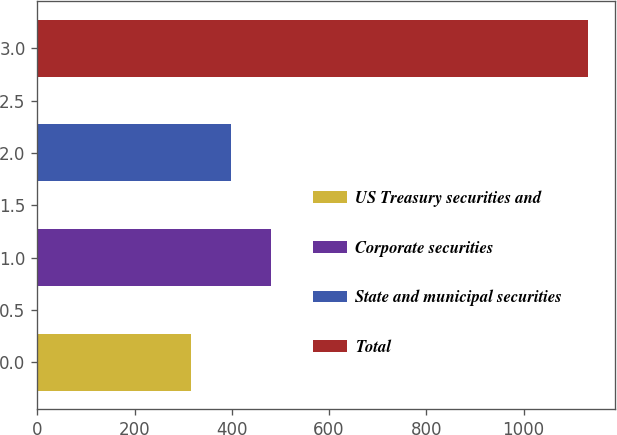Convert chart. <chart><loc_0><loc_0><loc_500><loc_500><bar_chart><fcel>US Treasury securities and<fcel>Corporate securities<fcel>State and municipal securities<fcel>Total<nl><fcel>317<fcel>480<fcel>398.5<fcel>1132<nl></chart> 